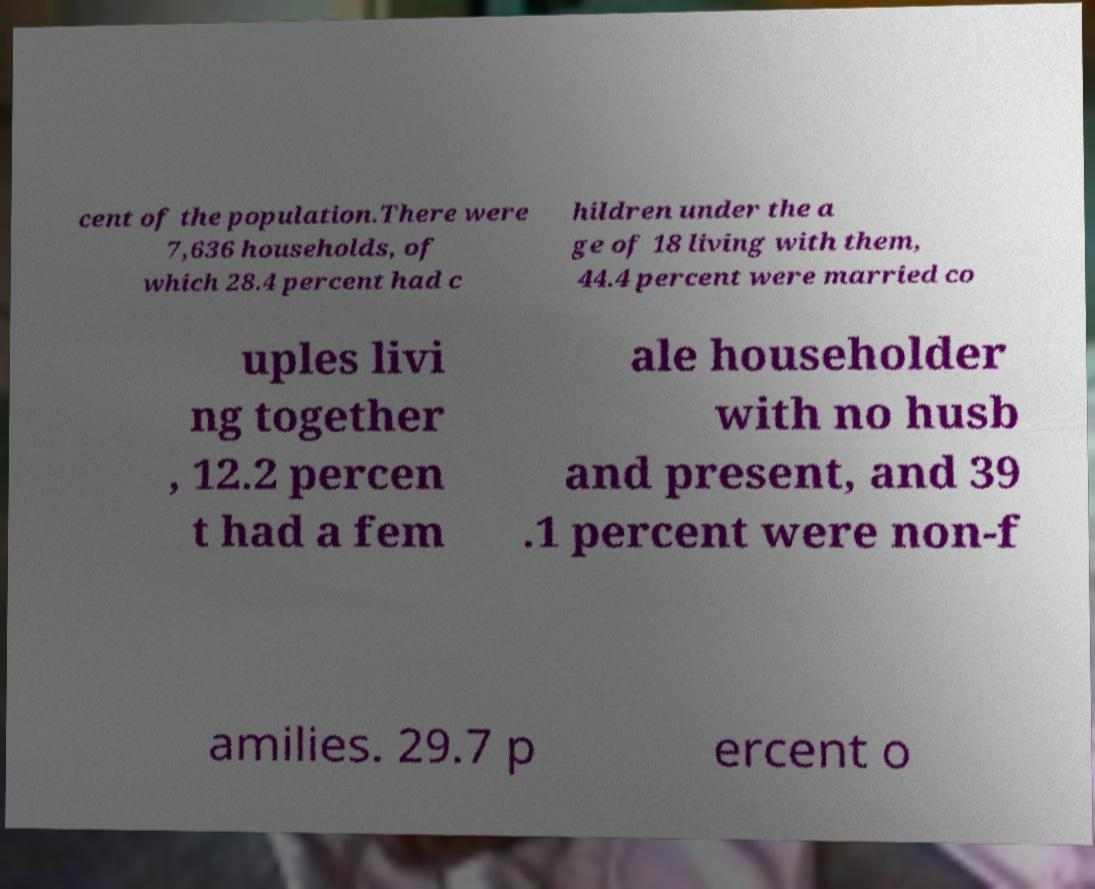Could you extract and type out the text from this image? cent of the population.There were 7,636 households, of which 28.4 percent had c hildren under the a ge of 18 living with them, 44.4 percent were married co uples livi ng together , 12.2 percen t had a fem ale householder with no husb and present, and 39 .1 percent were non-f amilies. 29.7 p ercent o 